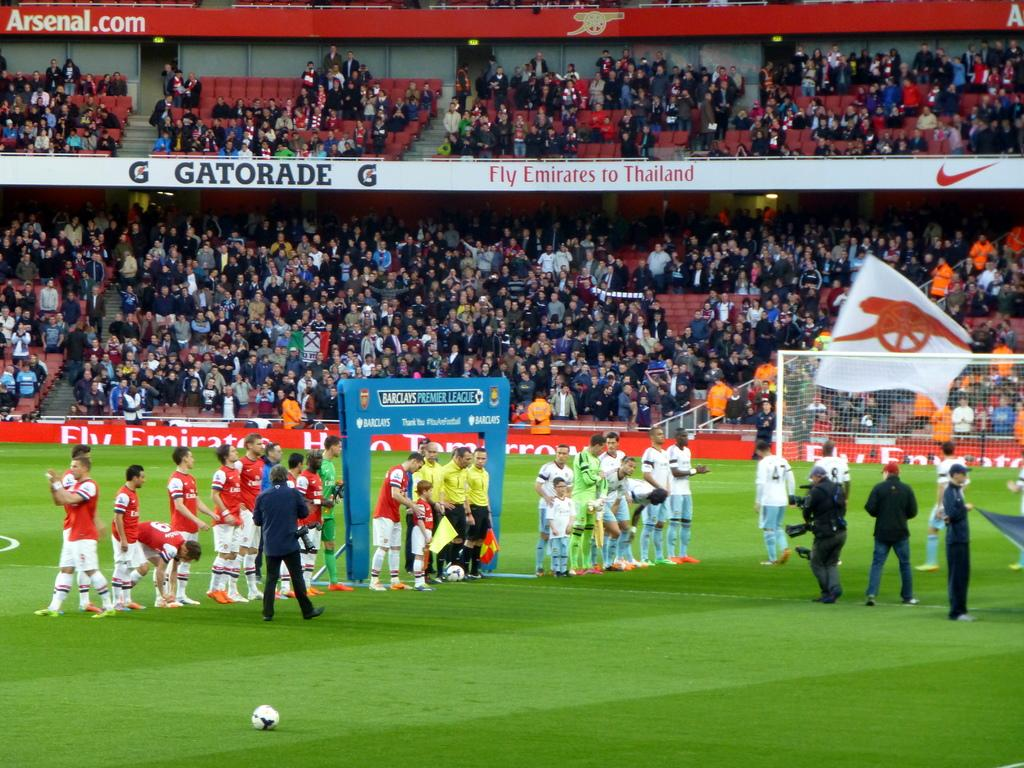<image>
Provide a brief description of the given image. A soccer field is shown with a GATORADE advertisement in the background. 